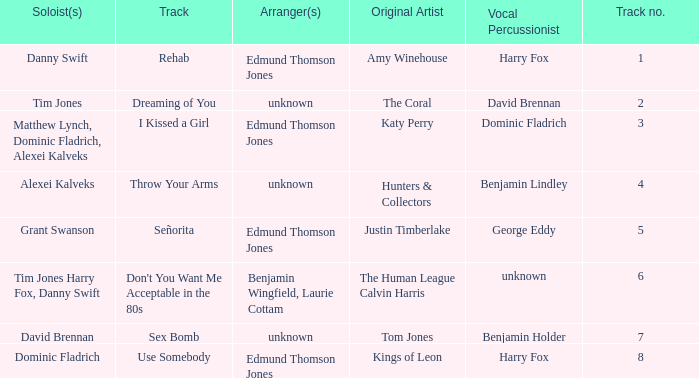Who is the original artist of "Use Somebody"? Kings of Leon. 